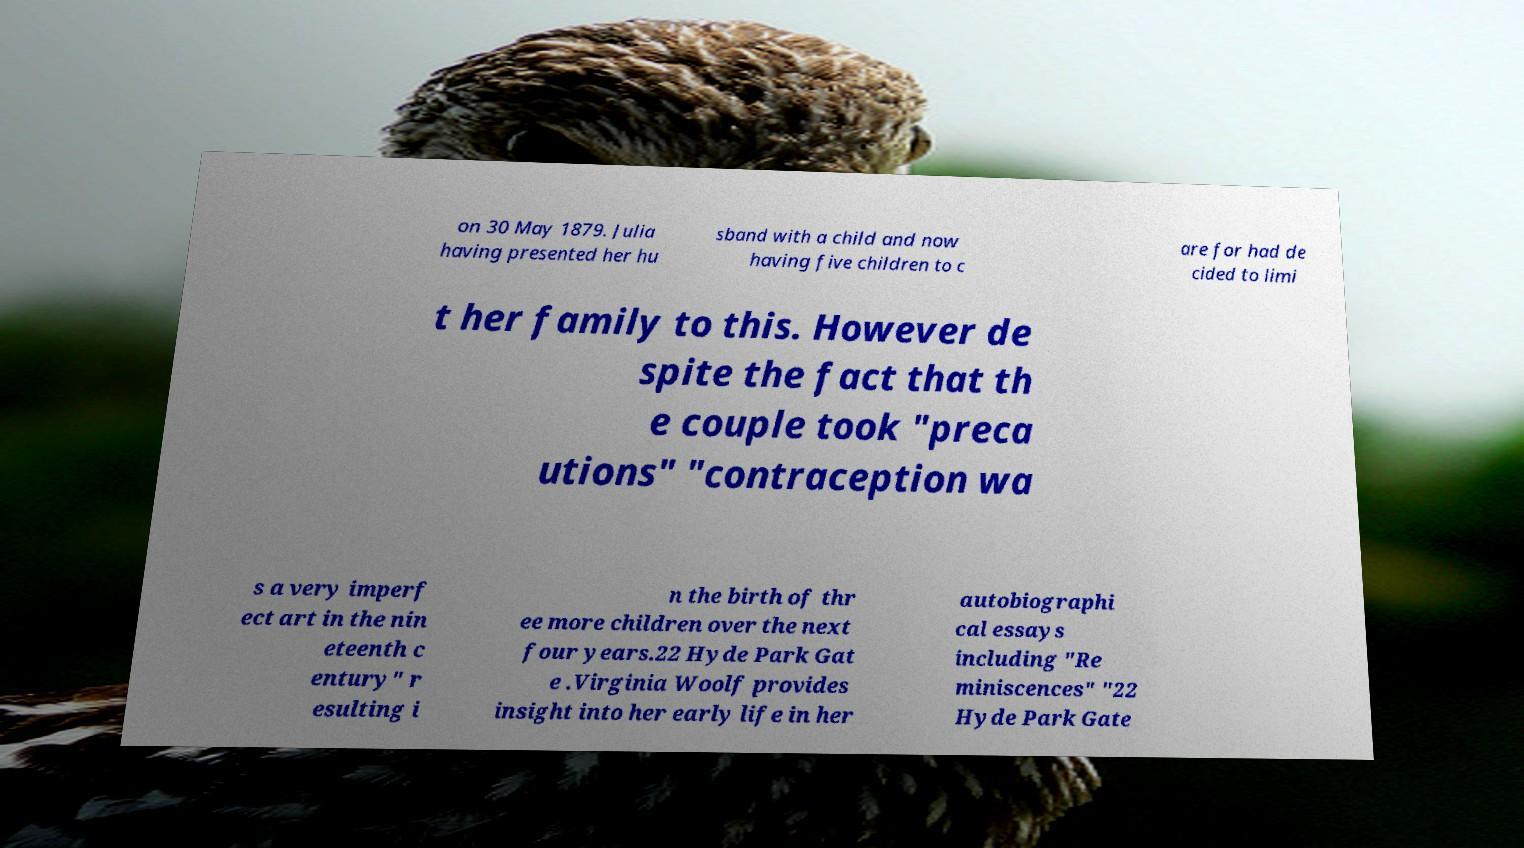Can you accurately transcribe the text from the provided image for me? on 30 May 1879. Julia having presented her hu sband with a child and now having five children to c are for had de cided to limi t her family to this. However de spite the fact that th e couple took "preca utions" "contraception wa s a very imperf ect art in the nin eteenth c entury" r esulting i n the birth of thr ee more children over the next four years.22 Hyde Park Gat e .Virginia Woolf provides insight into her early life in her autobiographi cal essays including "Re miniscences" "22 Hyde Park Gate 